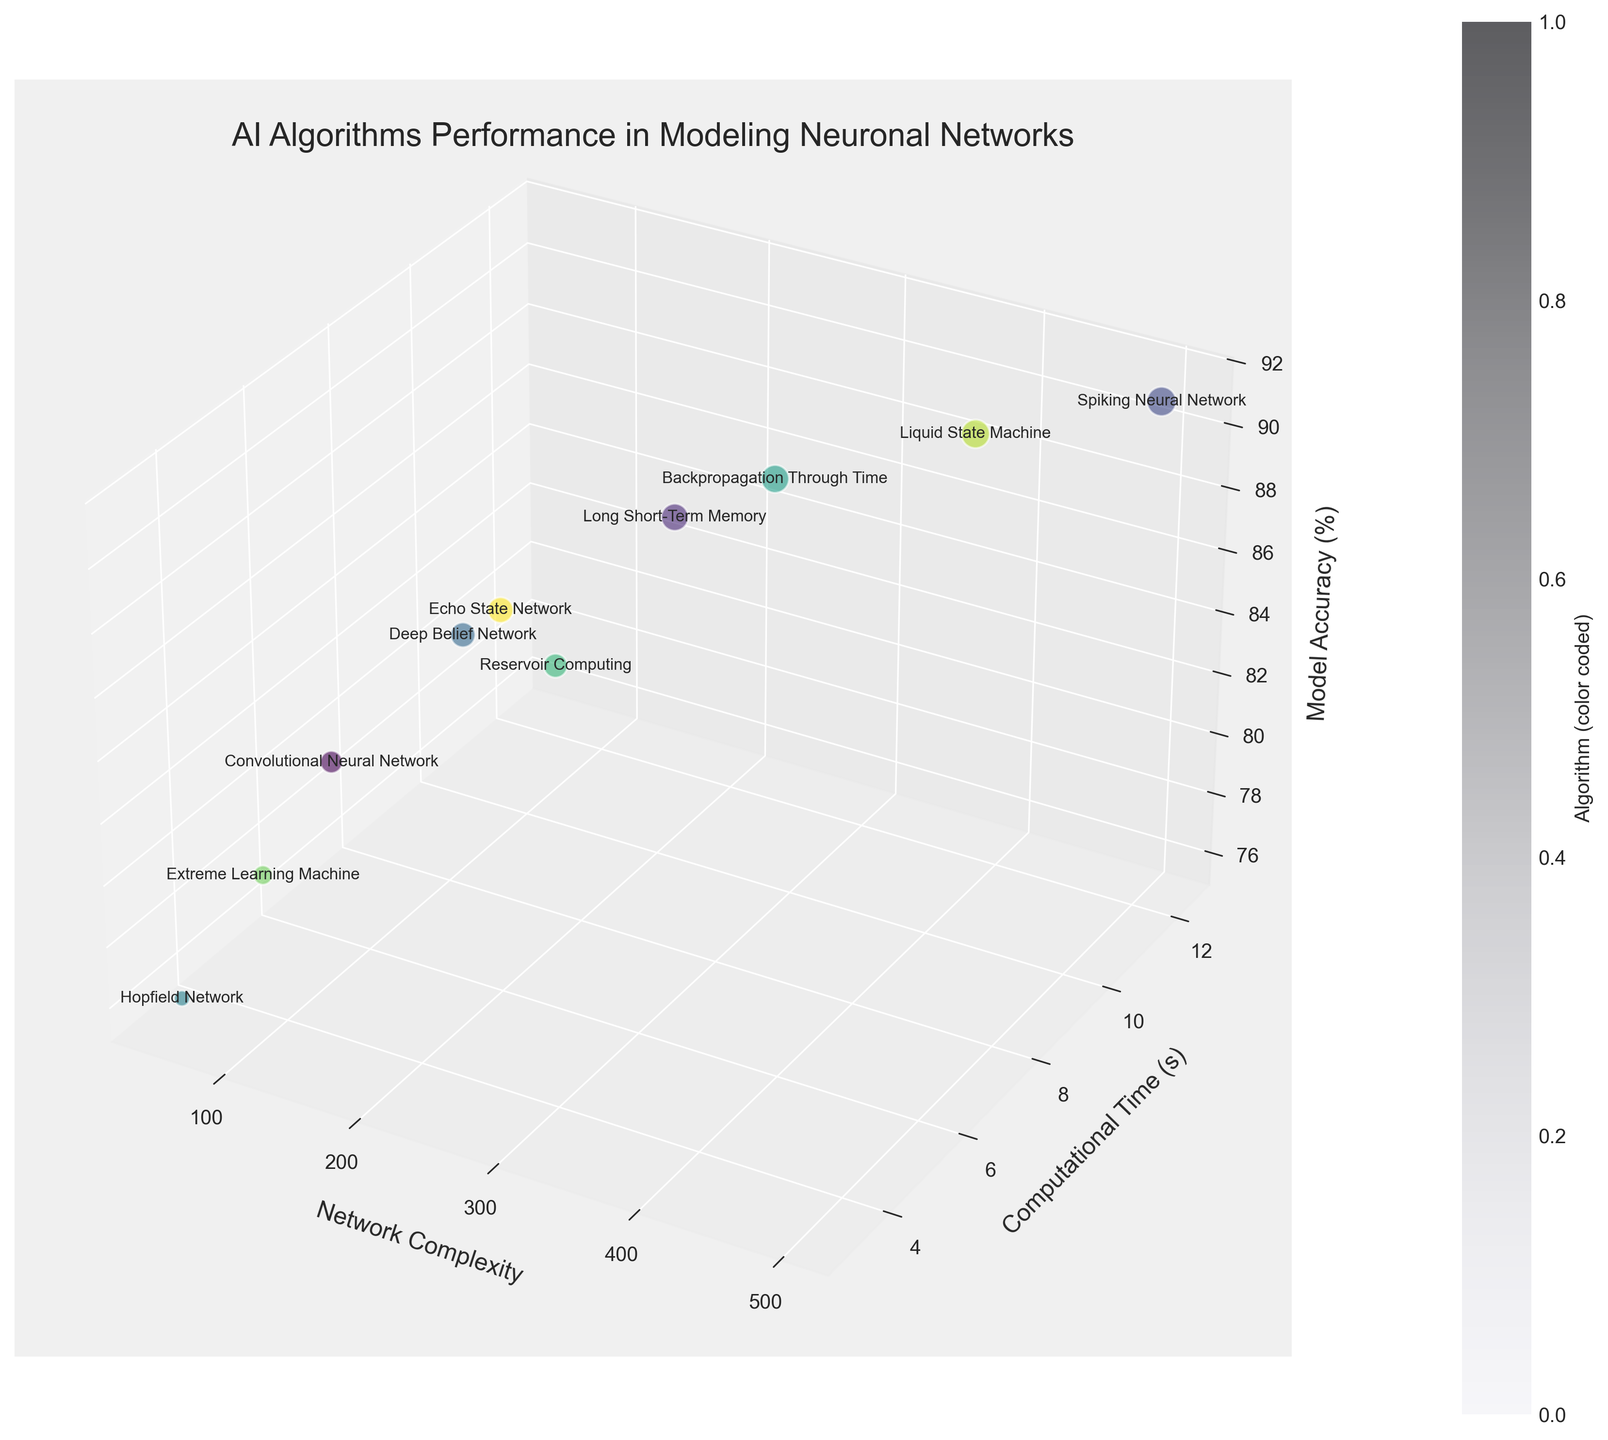What is the title of the figure? The title is located at the top center of the figure. It reads "AI Algorithms Performance in Modeling Neuronal Networks."
Answer: AI Algorithms Performance in Modeling Neuronal Networks How many AI algorithms are compared in the figure? By counting the bubbles and the corresponding labels, we can determine the number of data points representing different AI algorithms.
Answer: 10 Which AI algorithm shows the highest model accuracy? By examining the z-axis (Model Accuracy) and identifying the highest data point, along with its label, the Spiking Neural Network has the highest model accuracy at 91%.
Answer: Spiking Neural Network What is the network complexity level for the algorithm with the fastest computational time? By identifying the lowest point on the y-axis (Computational Time) and checking its corresponding x (Network Complexity) and text label, the Hopfield Network has the fastest computational time at 3.1 seconds and a network complexity of 50.
Answer: 50 Which algorithms have a model accuracy above 85%? By looking at the z-values on the chart (Model Accuracy) and noting the corresponding labels, Long Short-Term Memory, Spiking Neural Network, Deep Belief Network, Backpropagation Through Time, Liquid State Machine, and Echo State Network meet this criterion.
Answer: Long Short-Term Memory, Spiking Neural Network, Deep Belief Network, Backpropagation Through Time, Liquid State Machine, Echo State Network Compare the computational time and model accuracy of the Deep Belief Network and the Echo State Network. Which one is more efficient in terms of computational time? The computational time can be compared directly by looking at the y-values for both. Deep Belief Network has a computational time of 6.8 seconds, and Echo State Network has 6.9 seconds. So, the Deep Belief Network is slightly faster. Model accuracy is 85% for Deep Belief Network and 86% for Echo State Network. Hence, the Deep Belief Network is more efficient in terms of computational time.
Answer: Deep Belief Network What is the average model accuracy across all AI algorithms presented in the figure? The average model accuracy can be calculated by summing up all z-values and dividing by the total number of data points. Sum of accuracies: 82 + 88 + 91 + 85 + 76 + 89 + 84 + 79 + 90 + 86 = 850; Average = 850 / 10 = 85%.
Answer: 85% Which algorithm has the largest bubble size and what does it signify? The size of each bubble is dependent on model accuracy, the largest bubble signifies the Spiking Neural Network as it has the highest model accuracy of 91%.
Answer: Spiking Neural Network What is the median computational time for the algorithms? To calculate the median, list all y-values in ascending order and find the middle value. Computational times: 3.1, 4.3, 5.2, 6.8, 6.9, 7.4, 8.7, 9.5, 11.1, 12.3; Median = (6.9 + 7.4) / 2 = 7.15 seconds.
Answer: 7.15 seconds 